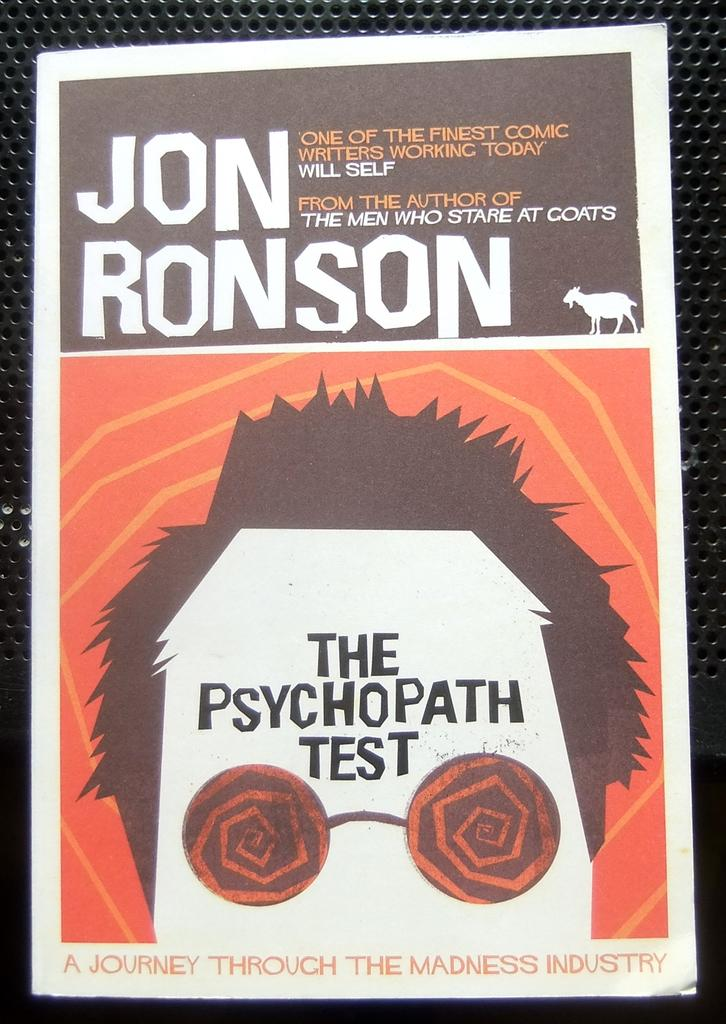Provide a one-sentence caption for the provided image. A book that says The Psychopathic Test on the cover. 